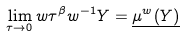<formula> <loc_0><loc_0><loc_500><loc_500>\lim _ { \tau \to 0 } w \tau ^ { \beta } w ^ { - 1 } Y = \underline { \mu ^ { w } ( Y ) }</formula> 